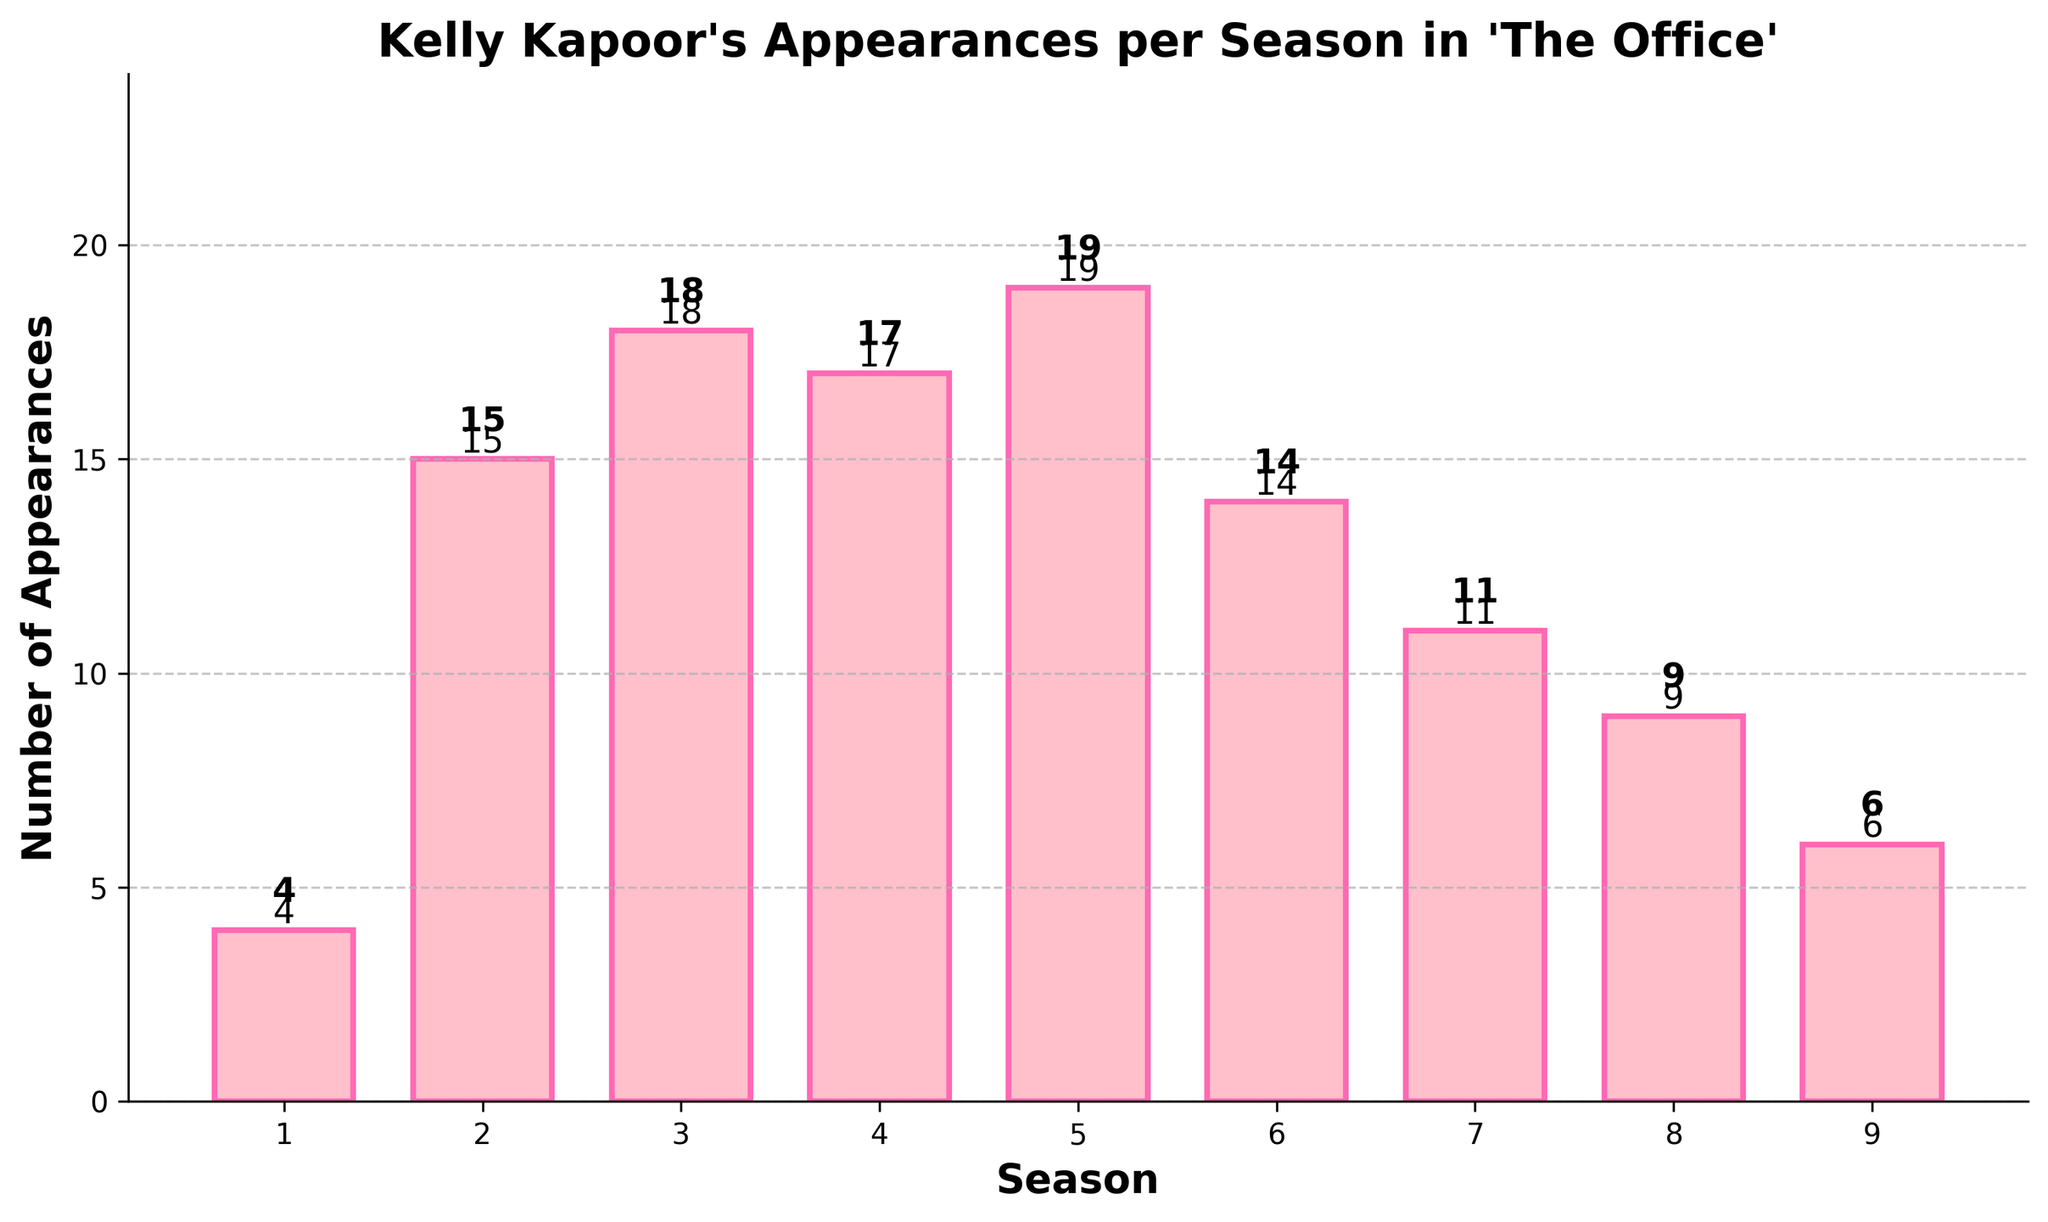How many total appearances did Kelly Kapoor make in Season 5? Find the height of the bar corresponding to Season 5, which represents the number of appearances. It is labeled as 19.
Answer: 19 What is the average number of Kelly Kapoor's appearances per season across all nine seasons? Sum all the appearances (4 + 15 + 18 + 17 + 19 + 14 + 11 + 9 + 6) and then divide by the number of seasons (9). The total is 113, and 113/9 is approximately 12.56.
Answer: 12.56 Which season has the highest number of appearances by Kelly Kapoor? Identify the tallest bar, which corresponds to Season 5 with 19 appearances.
Answer: Season 5 How did Kelly Kapoor's appearances change from Season 1 to Season 2? Compare the height of the bars for Season 1 (4 appearances) and Season 2 (15 appearances). There is an increase of 11 appearances.
Answer: Increased by 11 What is the total number of Kelly Kapoor's appearances in Seasons 3 and 4 combined? Add the number of appearances for Season 3 (18) and Season 4 (17), resulting in a total of 35.
Answer: 35 Between which consecutive seasons is there the largest drop in the number of appearances? Look for the largest difference between the heights of consecutive bars. The biggest drop is from Season 5 (19) to Season 6 (14), a decrease of 5 appearances.
Answer: Between Seasons 5 and 6 What is the median value of Kelly Kapoor’s appearances across the nine seasons? Order the number of appearances (4, 6, 9, 11, 14, 15, 17, 18, 19). The median value is the fifth number in this ordered list, which is 14.
Answer: 14 How many seasons have more than 10 appearances of Kelly Kapoor? Count the bars with heights greater than 10 (Seasons 2, 3, 4, 5, and 6). There are 5 such seasons.
Answer: 5 seasons Which color is used for the bars representing each season? Observe the color of the bars in the plot, noting they are a shade of pink.
Answer: Pink Do any seasons have an equal number of appearances by Kelly Kapoor? Check if any bars have the same height. No bars share the same height, so no seasons have equal appearances.
Answer: No 